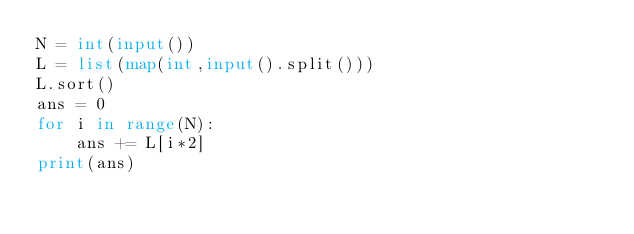Convert code to text. <code><loc_0><loc_0><loc_500><loc_500><_Python_>N = int(input())
L = list(map(int,input().split()))
L.sort()
ans = 0
for i in range(N):
    ans += L[i*2]
print(ans)</code> 